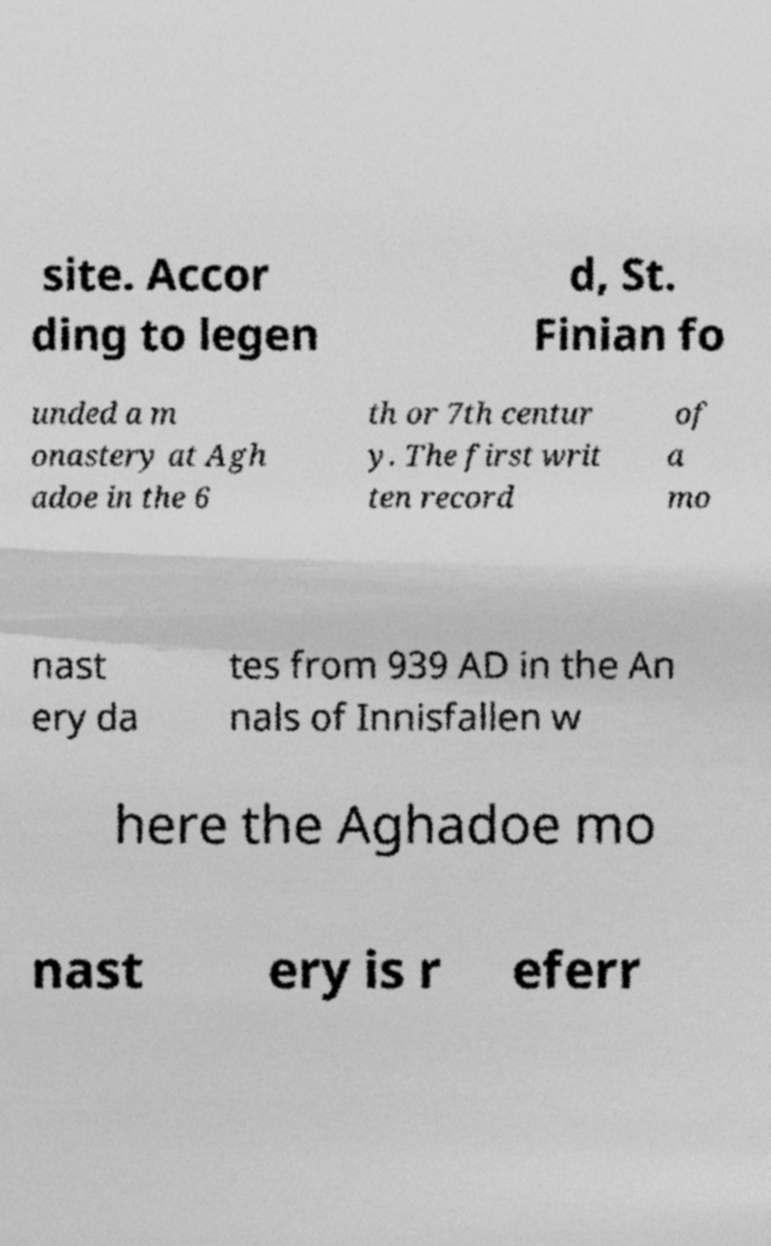There's text embedded in this image that I need extracted. Can you transcribe it verbatim? site. Accor ding to legen d, St. Finian fo unded a m onastery at Agh adoe in the 6 th or 7th centur y. The first writ ten record of a mo nast ery da tes from 939 AD in the An nals of Innisfallen w here the Aghadoe mo nast ery is r eferr 